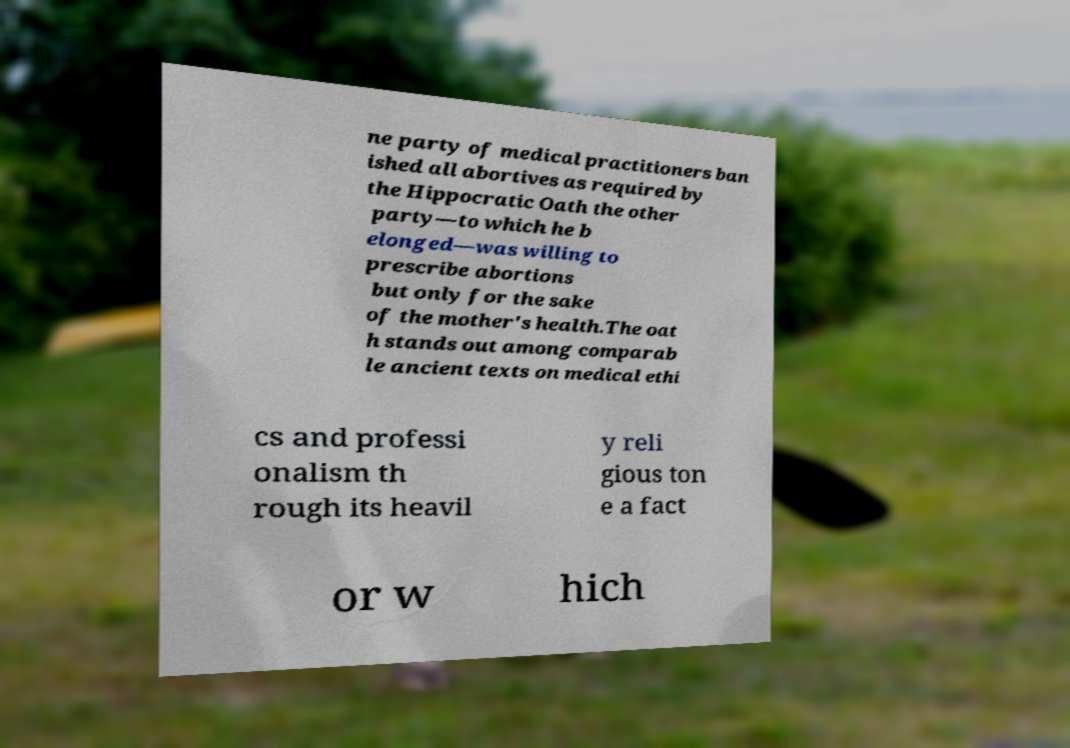I need the written content from this picture converted into text. Can you do that? ne party of medical practitioners ban ished all abortives as required by the Hippocratic Oath the other party—to which he b elonged—was willing to prescribe abortions but only for the sake of the mother's health.The oat h stands out among comparab le ancient texts on medical ethi cs and professi onalism th rough its heavil y reli gious ton e a fact or w hich 